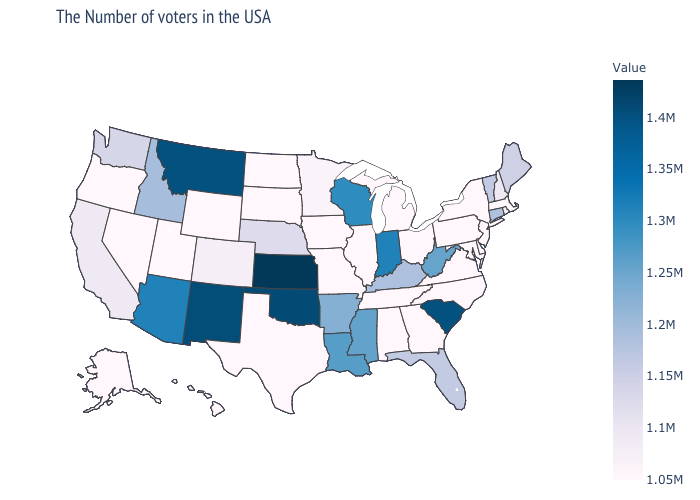Which states have the highest value in the USA?
Keep it brief. Kansas. Does the map have missing data?
Answer briefly. No. Which states have the lowest value in the South?
Keep it brief. Delaware, Maryland, Virginia, North Carolina, Georgia, Alabama, Tennessee, Texas. 